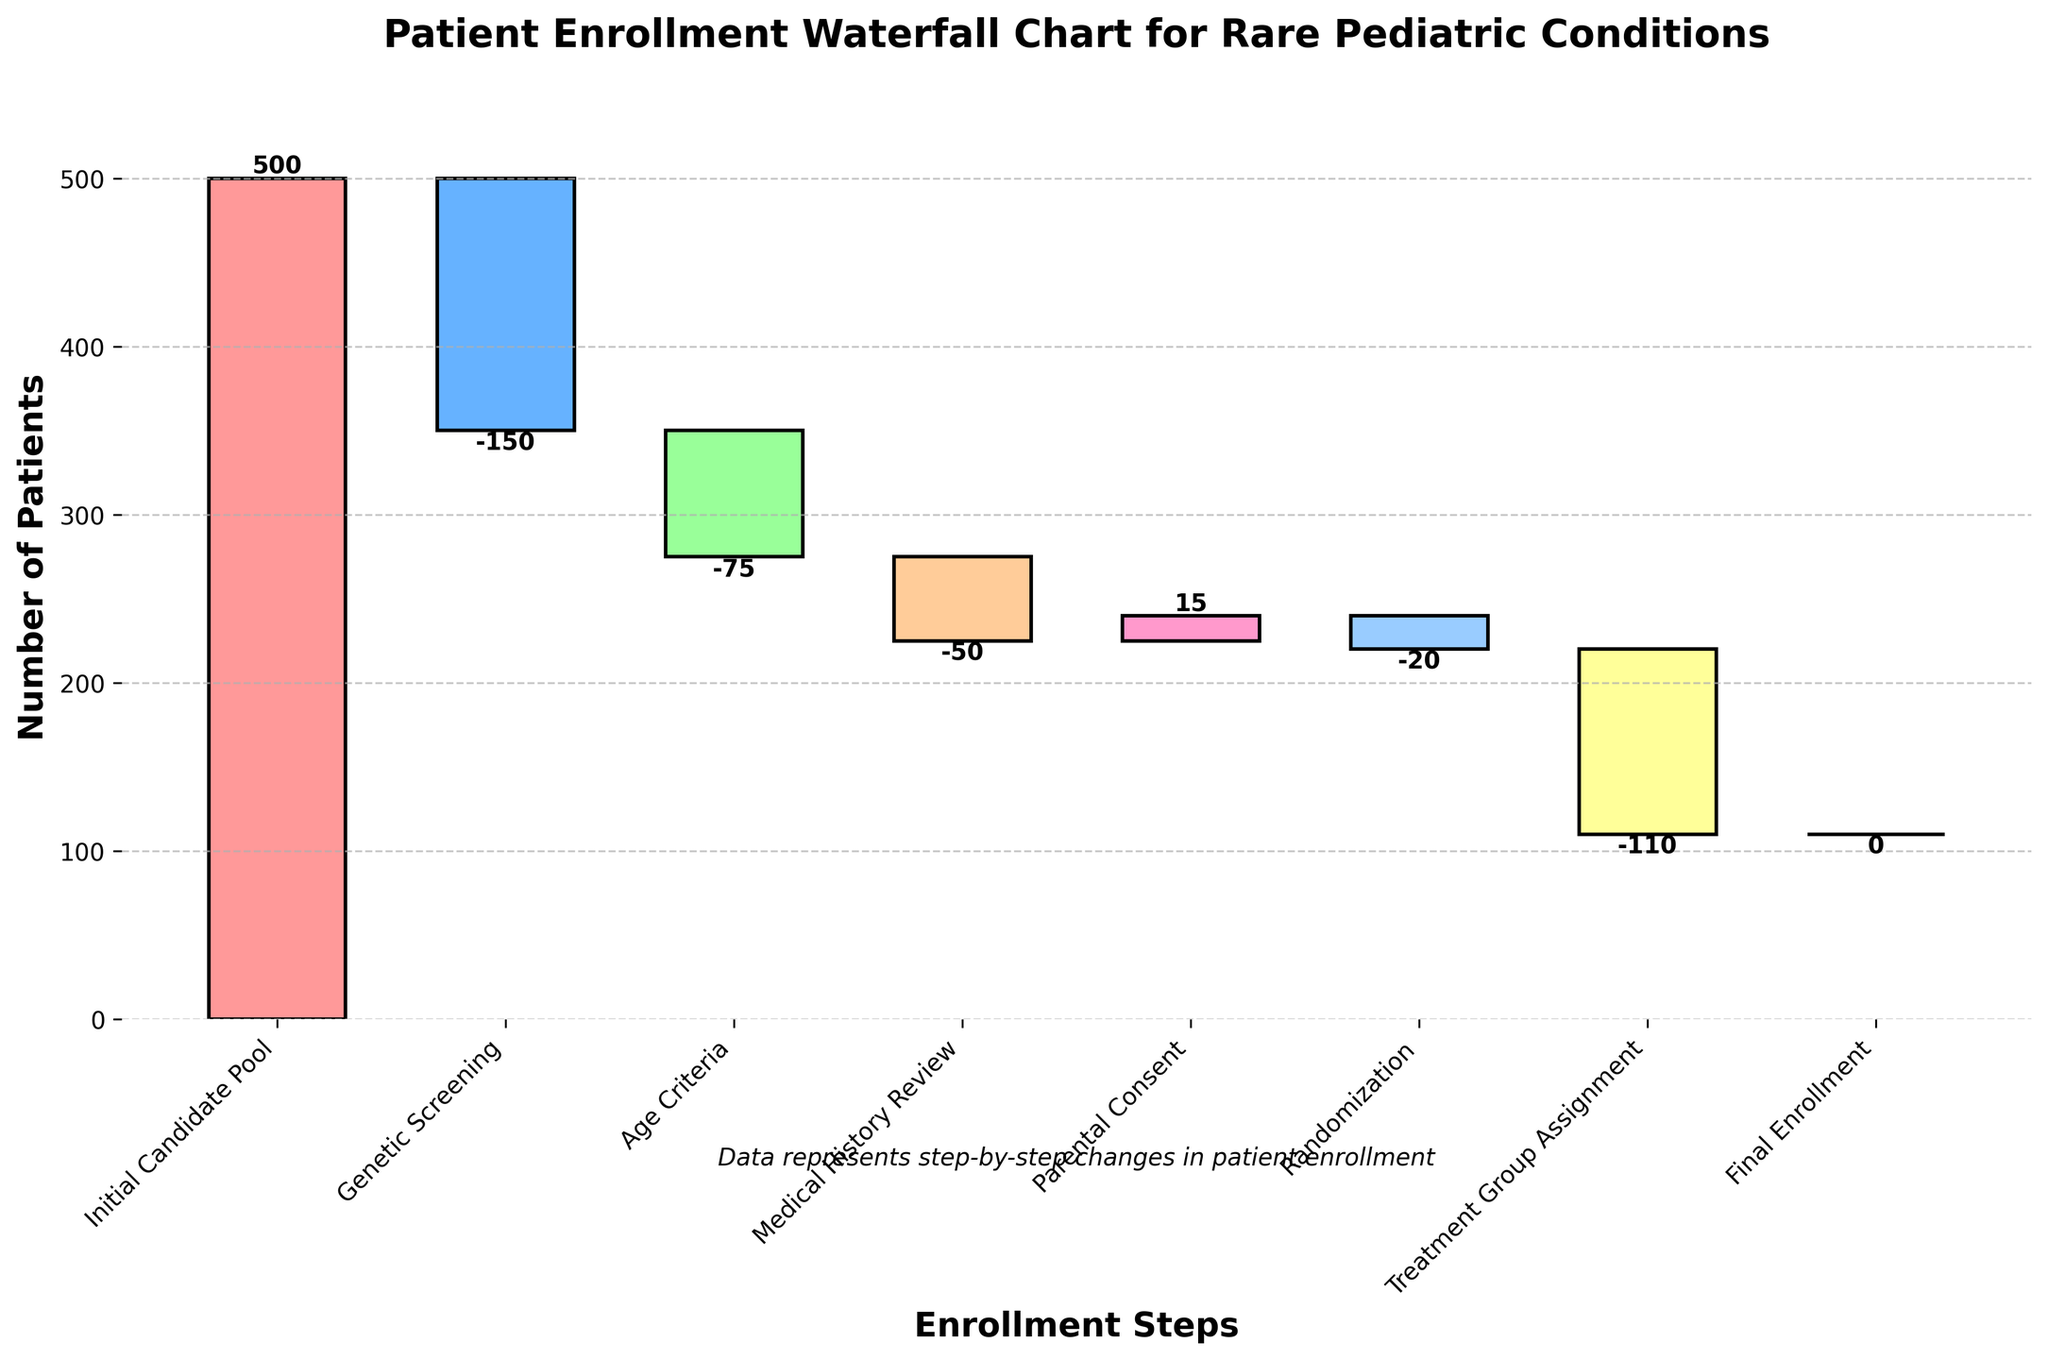How many patients were in the Initial Candidate Pool? The value representing the Initial Candidate Pool is labeled on the y-axis at the starting point of the waterfall chart. Here, it is 500 patients.
Answer: 500 What is the net change in patient count after the Genetic Screening step? The waterfall chart shows the number of patients removed at each step. After the Genetic Screening step, the number of patients decreases by 150.
Answer: -150 How many patients were added after the Parental Consent step? The figure shows a positive change at the Parental Consent step, which is labeled directly on the chart. Here, it indicates an increase of 15 patients.
Answer: 15 What was the cumulative number of patients before the Age Criteria step? The cumulative count before the Age Criteria step is the initial pool minus the patients lost during Genetic Screening: 500 - 150 = 350.
Answer: 350 Which step had the biggest reduction in patient numbers? We identify the step with the greatest negative value. According to the chart, Treatment Group Assignment has the largest reduction, equal to 110 patients.
Answer: Treatment Group Assignment Compare the number of patients excluded during Age Criteria and Medical History Review. Which is higher and by how much? Age Criteria excludes 75 patients and Medical History Review excludes 50. The difference is 75 - 50 = 25. Therefore, Age Criteria excludes 25 more patients than Medical History Review.
Answer: Age Criteria by 25 What is the final enrollment count of eligible patients? The final number of enrolled patients is shown at the end of the waterfall chart, labeled as Final Enrollment. It remains constant at 110 patients.
Answer: 110 What is the total number of steps involved in the patient enrollment process? The x-axis labels each step involved. Counting these labels, there are 8 steps in total.
Answer: 8 How many patients were lost during the Randomization step? The Randomization step is highlighted in the waterfall chart showing a decline. The number of patients lost here is 20, as labeled directly on the chart.
Answer: 20 How does the change in patient number from Parental Consent compare to that from Age Criteria? The Parental Consent step shows a gain of 15 patients, while the Age Criteria step shows a loss of 75 patients. Comparatively, the change from Parental Consent is less severe since it’s a gain while Age Criteria is a significant loss.
Answer: Parental Consent is less severe 